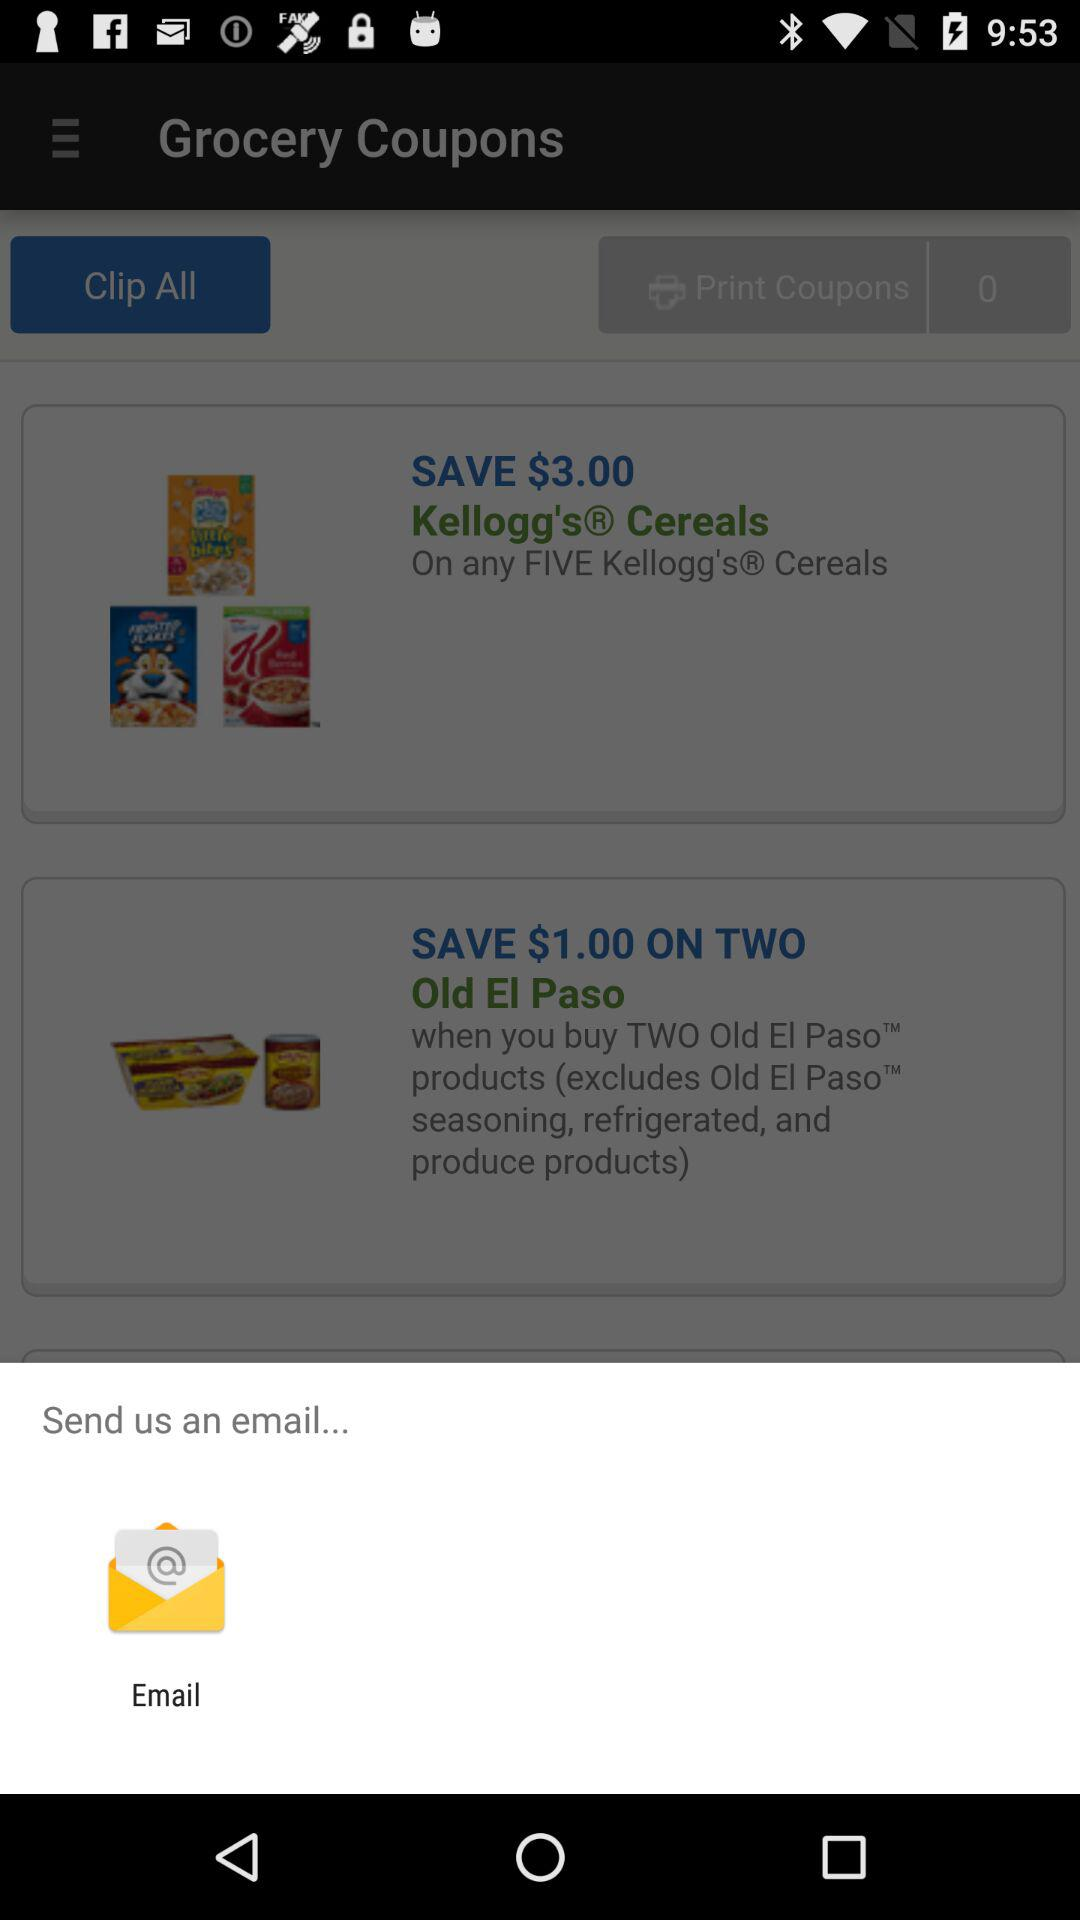How many "Print Coupons" are there? There are 0 "Print Coupons". 